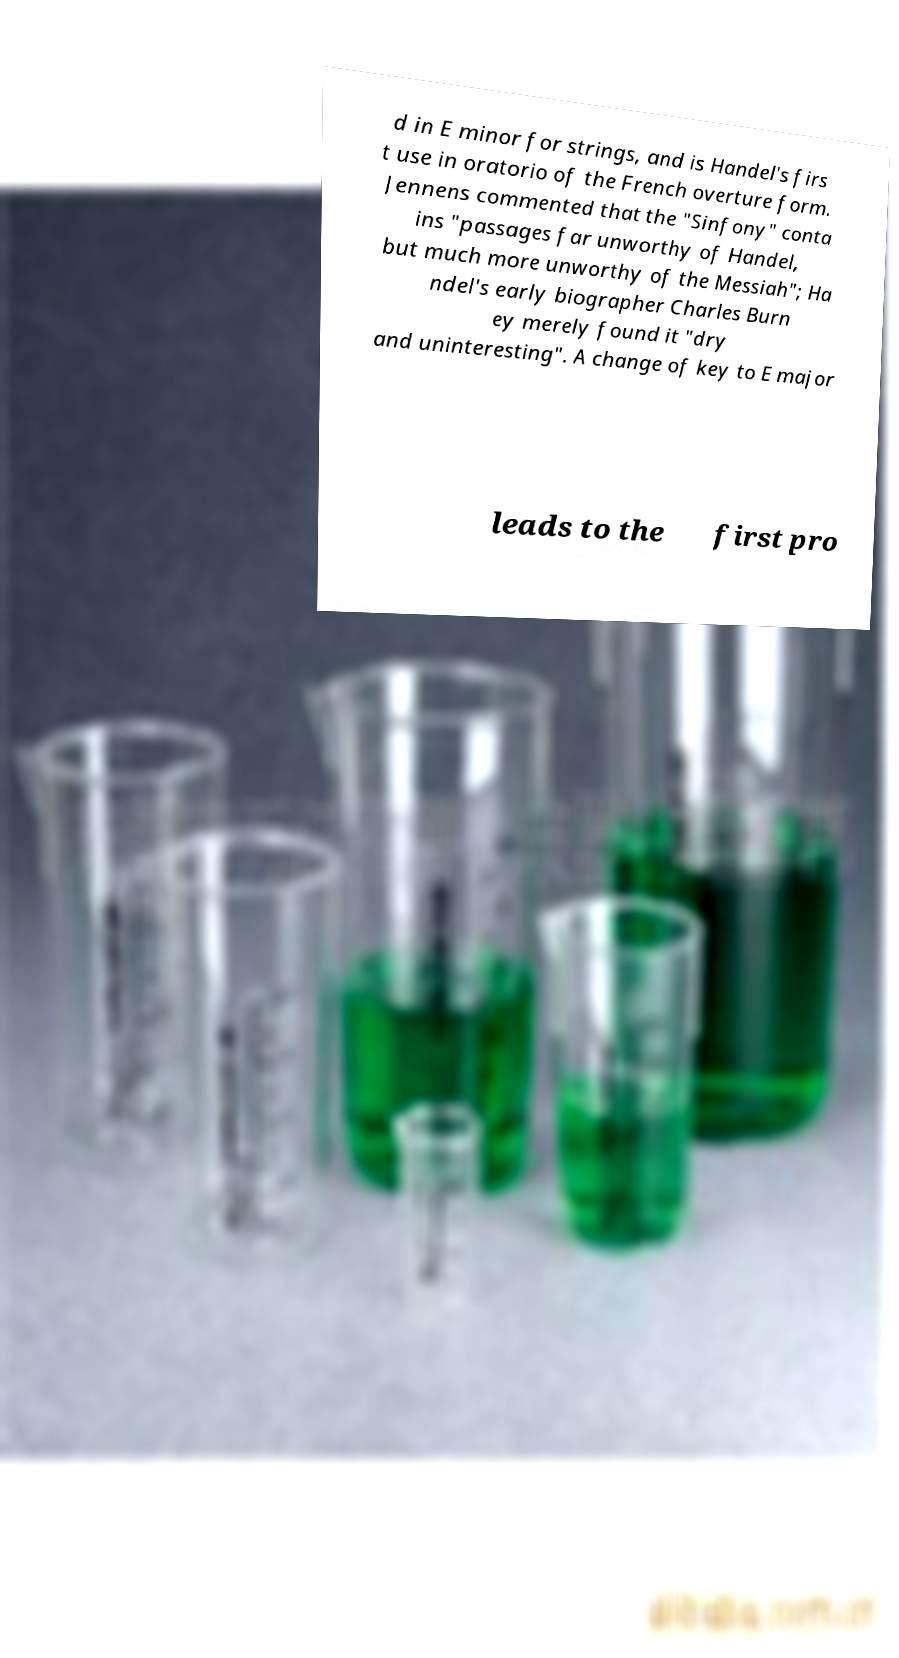I need the written content from this picture converted into text. Can you do that? d in E minor for strings, and is Handel's firs t use in oratorio of the French overture form. Jennens commented that the "Sinfony" conta ins "passages far unworthy of Handel, but much more unworthy of the Messiah"; Ha ndel's early biographer Charles Burn ey merely found it "dry and uninteresting". A change of key to E major leads to the first pro 